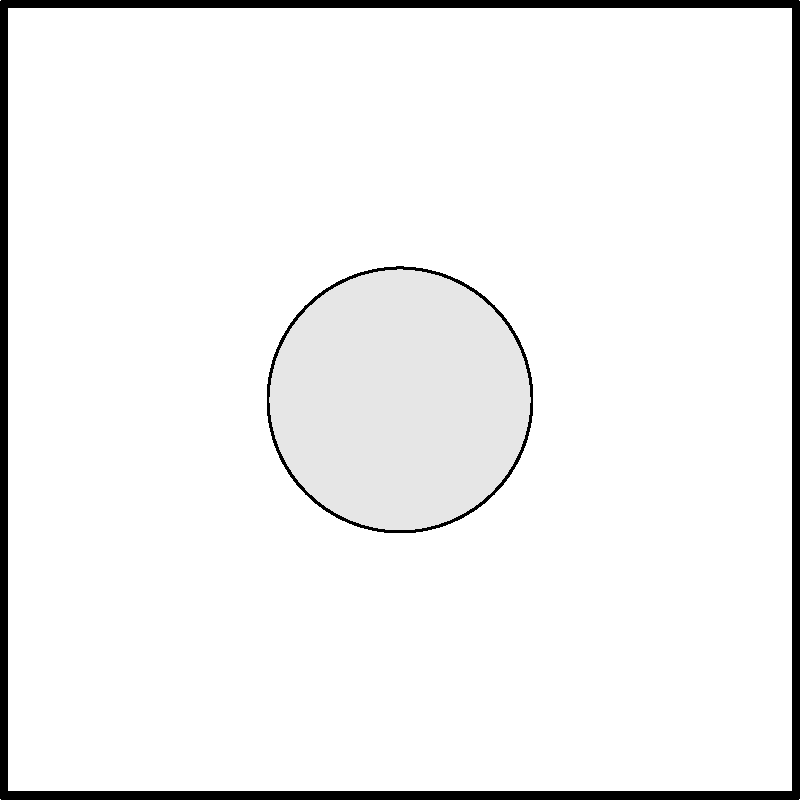As a tennis enthusiast, you're analyzing the forces acting on a tennis racket during ball impact. The diagram shows a simplified representation of these forces. If the normal force $F_n$ is 100 N and the angle $\theta$ between $F_n$ and each of the lateral forces ($F_l$ and $F_r$) is 45°, calculate the magnitude of one lateral force (either $F_l$ or $F_r$) assuming they are equal. Let's approach this step-by-step:

1) First, we need to understand that the lateral forces ($F_l$ and $F_r$) are symmetrical and equal in magnitude due to the symmetry of the racket and the impact.

2) The normal force $F_n$ and the two lateral forces form a right-angled triangle, where $F_n$ is the hypotenuse.

3) Since the angle between $F_n$ and each lateral force is 45°, this forms a special right triangle where the two legs (lateral forces) are equal.

4) In a 45-45-90 triangle, the ratio of a leg to the hypotenuse is $1:\sqrt{2}$.

5) We can express this mathematically:
   $$F_l = F_r = \frac{F_n}{\sqrt{2}}$$

6) Given $F_n = 100$ N, we can calculate $F_l$ or $F_r$:
   $$F_l = F_r = \frac{100}{\sqrt{2}} \approx 70.71 \text{ N}$$

7) Therefore, each lateral force has a magnitude of approximately 70.71 N.
Answer: 70.71 N 